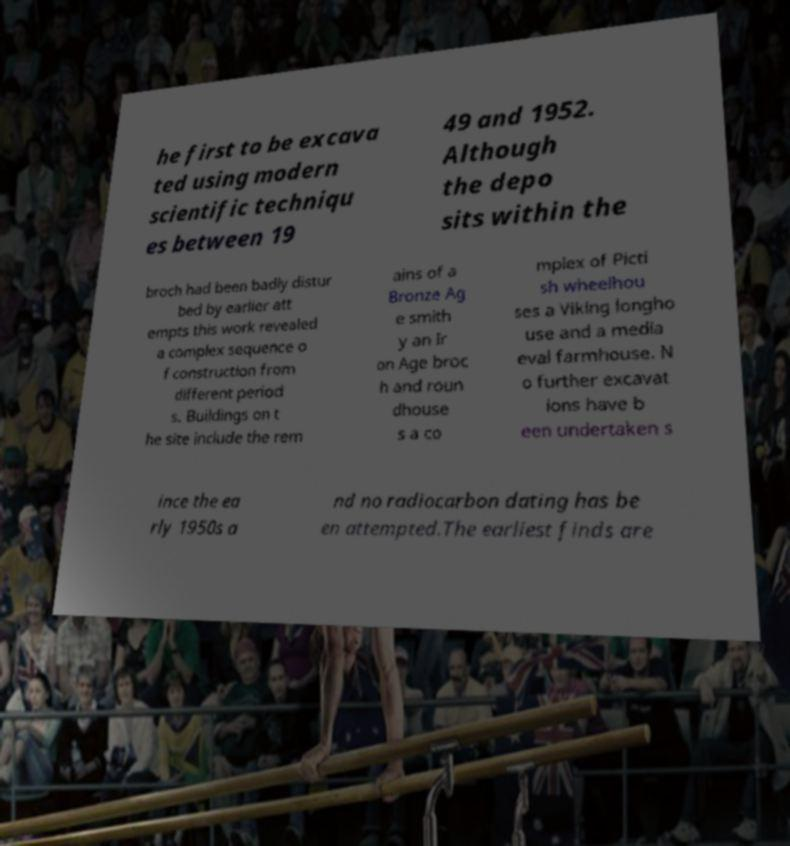Please identify and transcribe the text found in this image. he first to be excava ted using modern scientific techniqu es between 19 49 and 1952. Although the depo sits within the broch had been badly distur bed by earlier att empts this work revealed a complex sequence o f construction from different period s. Buildings on t he site include the rem ains of a Bronze Ag e smith y an Ir on Age broc h and roun dhouse s a co mplex of Picti sh wheelhou ses a Viking longho use and a media eval farmhouse. N o further excavat ions have b een undertaken s ince the ea rly 1950s a nd no radiocarbon dating has be en attempted.The earliest finds are 